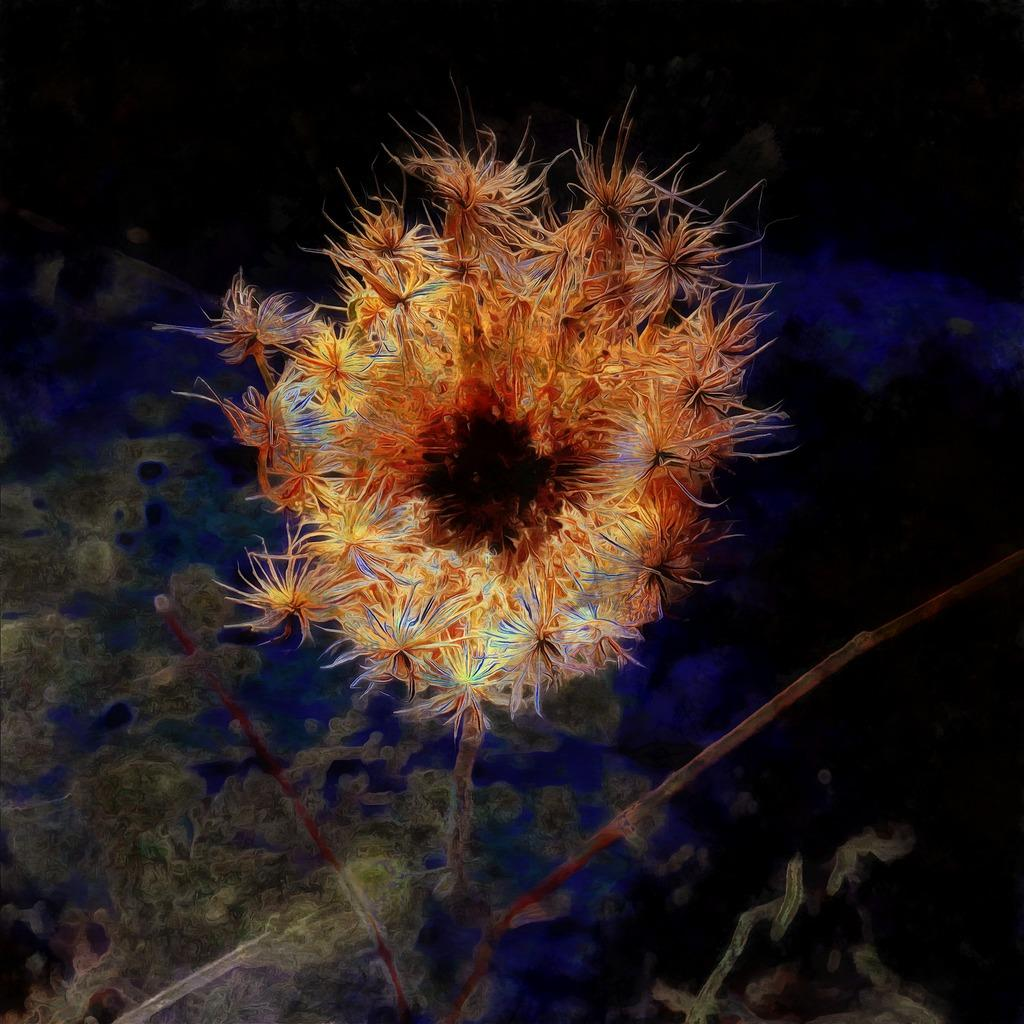What is the main subject of the image? There is a flower under the water in the image. Are there any other objects visible in the image besides the flower? Yes, there are other objects visible in the image. How would you describe the lighting in the image? The top of the image appears to be dark. What type of dinosaurs can be seen swimming in the water with the flower? There are no dinosaurs present in the image; it features a flower under the water. What kind of glue is being used to hold the flower in place? There is no glue present in the image, and the flower is naturally submerged in the water. 